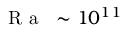<formula> <loc_0><loc_0><loc_500><loc_500>{ R a } \sim 1 0 ^ { 1 1 }</formula> 